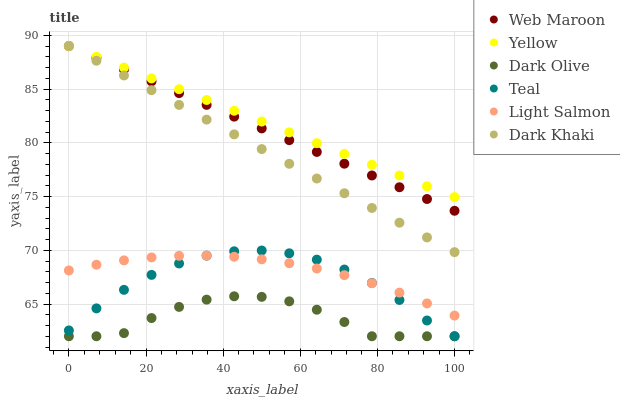Does Dark Olive have the minimum area under the curve?
Answer yes or no. Yes. Does Yellow have the maximum area under the curve?
Answer yes or no. Yes. Does Web Maroon have the minimum area under the curve?
Answer yes or no. No. Does Web Maroon have the maximum area under the curve?
Answer yes or no. No. Is Yellow the smoothest?
Answer yes or no. Yes. Is Dark Olive the roughest?
Answer yes or no. Yes. Is Web Maroon the smoothest?
Answer yes or no. No. Is Web Maroon the roughest?
Answer yes or no. No. Does Dark Olive have the lowest value?
Answer yes or no. Yes. Does Web Maroon have the lowest value?
Answer yes or no. No. Does Dark Khaki have the highest value?
Answer yes or no. Yes. Does Dark Olive have the highest value?
Answer yes or no. No. Is Light Salmon less than Web Maroon?
Answer yes or no. Yes. Is Light Salmon greater than Dark Olive?
Answer yes or no. Yes. Does Yellow intersect Web Maroon?
Answer yes or no. Yes. Is Yellow less than Web Maroon?
Answer yes or no. No. Is Yellow greater than Web Maroon?
Answer yes or no. No. Does Light Salmon intersect Web Maroon?
Answer yes or no. No. 